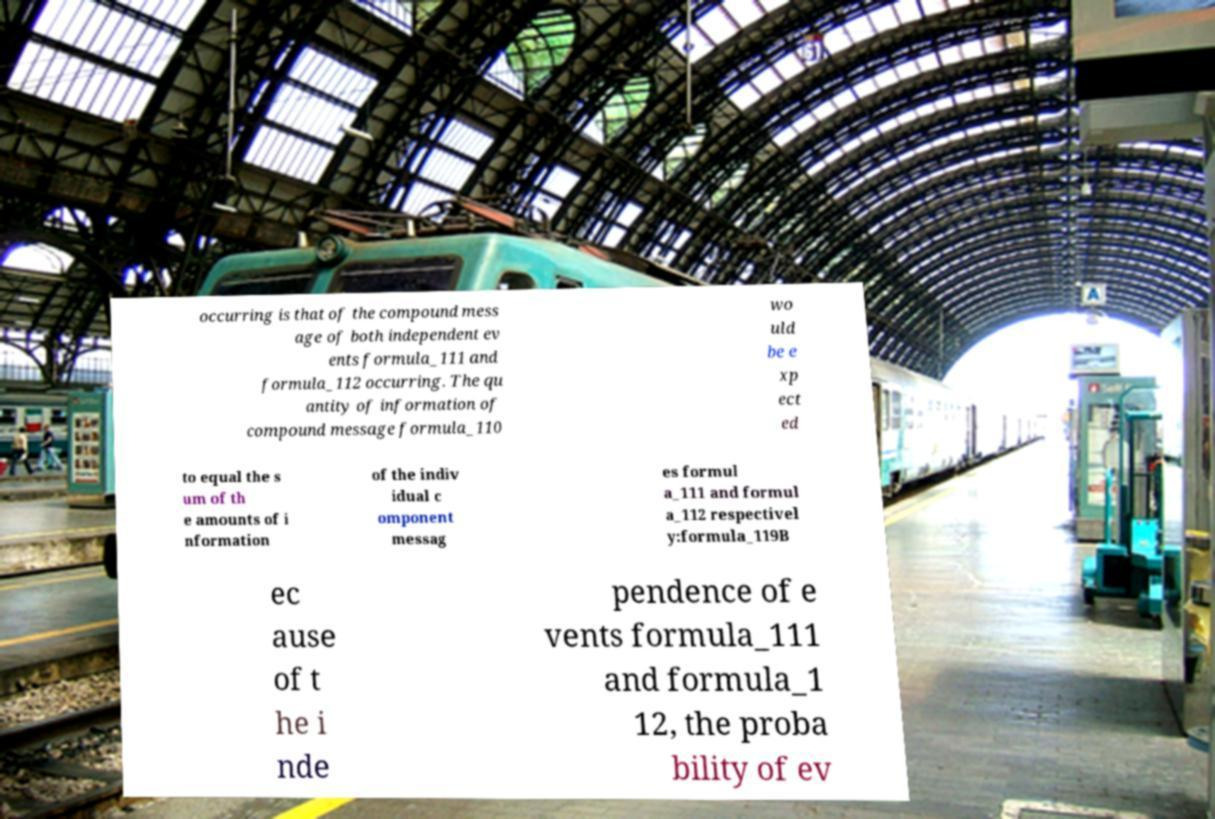Please identify and transcribe the text found in this image. occurring is that of the compound mess age of both independent ev ents formula_111 and formula_112 occurring. The qu antity of information of compound message formula_110 wo uld be e xp ect ed to equal the s um of th e amounts of i nformation of the indiv idual c omponent messag es formul a_111 and formul a_112 respectivel y:formula_119B ec ause of t he i nde pendence of e vents formula_111 and formula_1 12, the proba bility of ev 